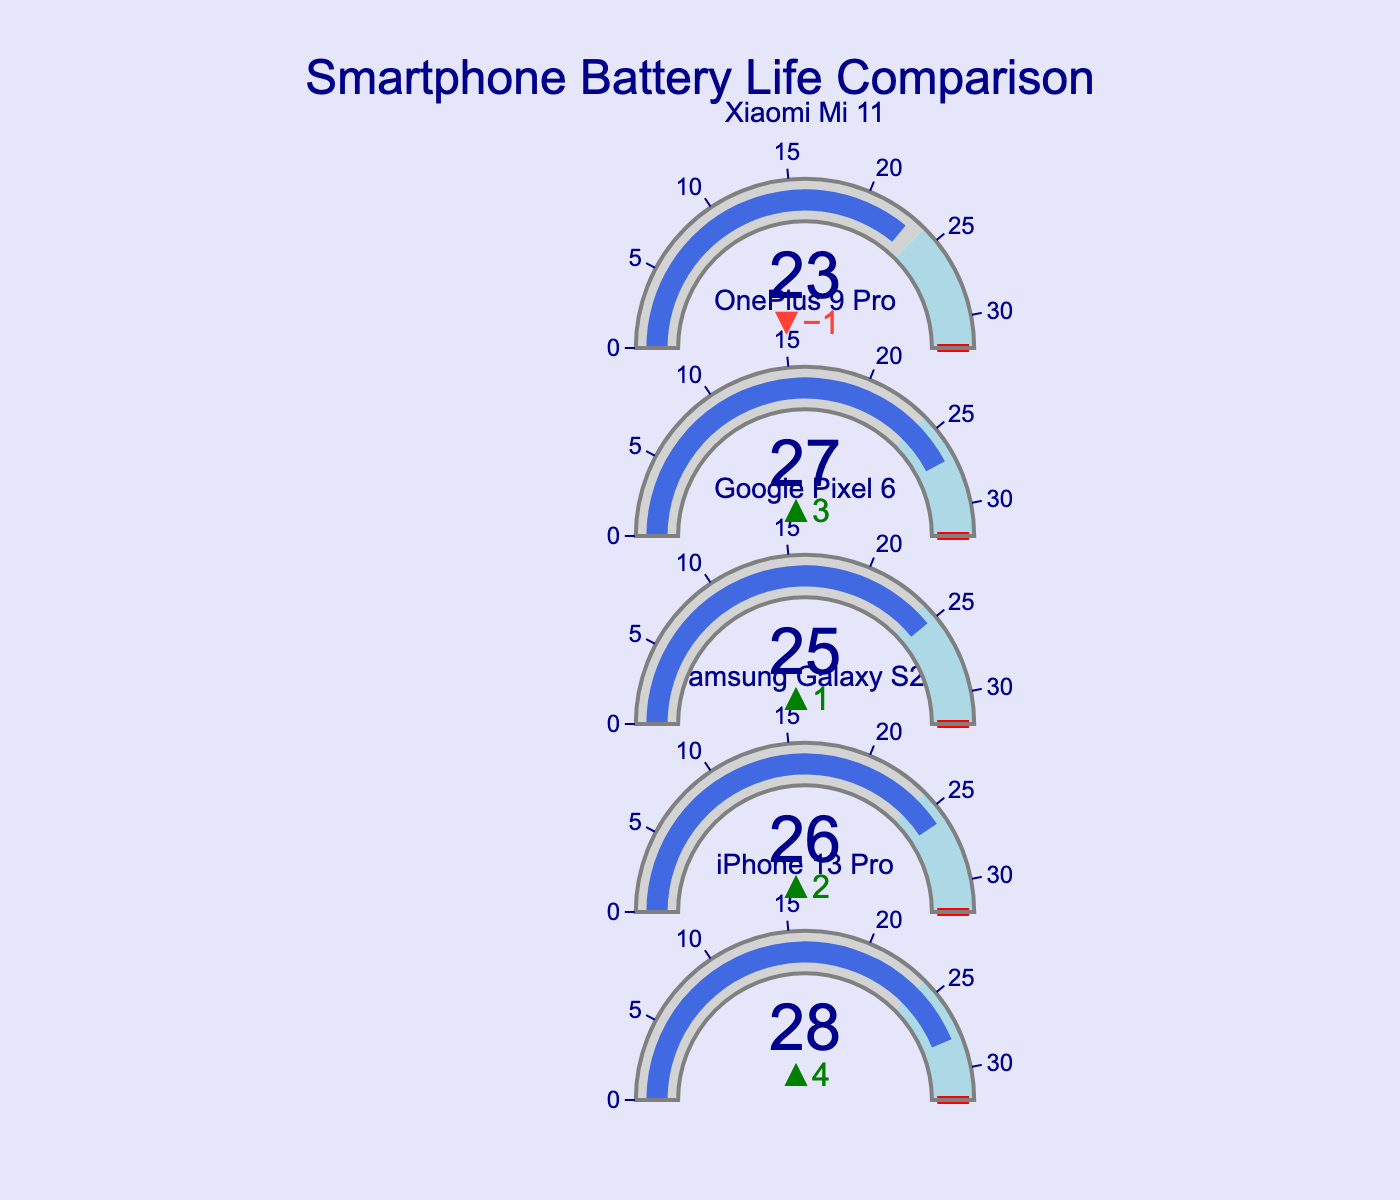What is the title of the figure? The title can be found at the top of the figure in larger font size. It reads "Smartphone Battery Life Comparison".
Answer: Smartphone Battery Life Comparison Which smartphone model has the highest battery life? By observing the figure, we can see that each model's battery life is represented by a bar. The iPhone 13 Pro has the longest bar, indicating the highest battery life.
Answer: iPhone 13 Pro How much higher is the battery life of the Samsung Galaxy S21 compared to the industry average? First, identify the battery life of the Samsung Galaxy S21, which is 26 hours. Then, note the industry average, which is 24 hours. Subtract the industry average from the battery life of the Samsung Galaxy S21 (26 - 24).
Answer: 2 hours Which model has a battery life below the industry average? Check the length of the bars against the industry average line. The Xiaomi Mi 11's bar is shorter than the industry average line.
Answer: Xiaomi Mi 11 What is the difference in battery life between the OnePlus 9 Pro and the Google Pixel 6? Find the battery life of the OnePlus 9 Pro (27 hours) and the Google Pixel 6 (25 hours). Subtract the battery life of the Google Pixel 6 from the OnePlus 9 Pro (27 - 25).
Answer: 2 hours How does the battery life of the iPhone 13 Pro compare to the best in class? The iPhone 13 Pro has a battery life of 28 hours. The best in class is marked at 32 hours. Subtract the iPhone 13 Pro's battery life from the best in class (32 - 28).
Answer: 4 hours Which smartphone models have a battery life exceeding 26 hours? Identify the bars that extend beyond the 26-hour mark. The iPhone 13 Pro and the OnePlus 9 Pro both exceed this mark.
Answer: iPhone 13 Pro, OnePlus 9 Pro Is the battery life of the Xiaomi Mi 11 within the industry average range to best in class range? The Xiaomi Mi 11 has a battery life of 23 hours, while the industry average is 24 hours. Since 23 is less than 24, it falls below the industry average range.
Answer: No What is the range of the battery life in the figure? Identify the minimum and maximum battery life values by observing the bars. The minimum battery life is 23 hours (Xiaomi Mi 11), and the maximum is 28 hours (iPhone 13 Pro). Subtract the minimum from the maximum (28 - 23).
Answer: 5 hours Which models have a delta value (difference from the industry average) of 2 hours? Check the delta values for each smartphone. The Samsung Galaxy S21 and the OnePlus 9 Pro both have a delta value of +2 hours from the industry average.
Answer: Samsung Galaxy S21, OnePlus 9 Pro 